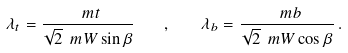Convert formula to latex. <formula><loc_0><loc_0><loc_500><loc_500>\lambda _ { t } = \frac { \ m t } { \sqrt { 2 } \ m W \sin \beta } \quad , \quad \lambda _ { b } = \frac { \ m b } { \sqrt { 2 } \ m W \cos \beta } \, .</formula> 